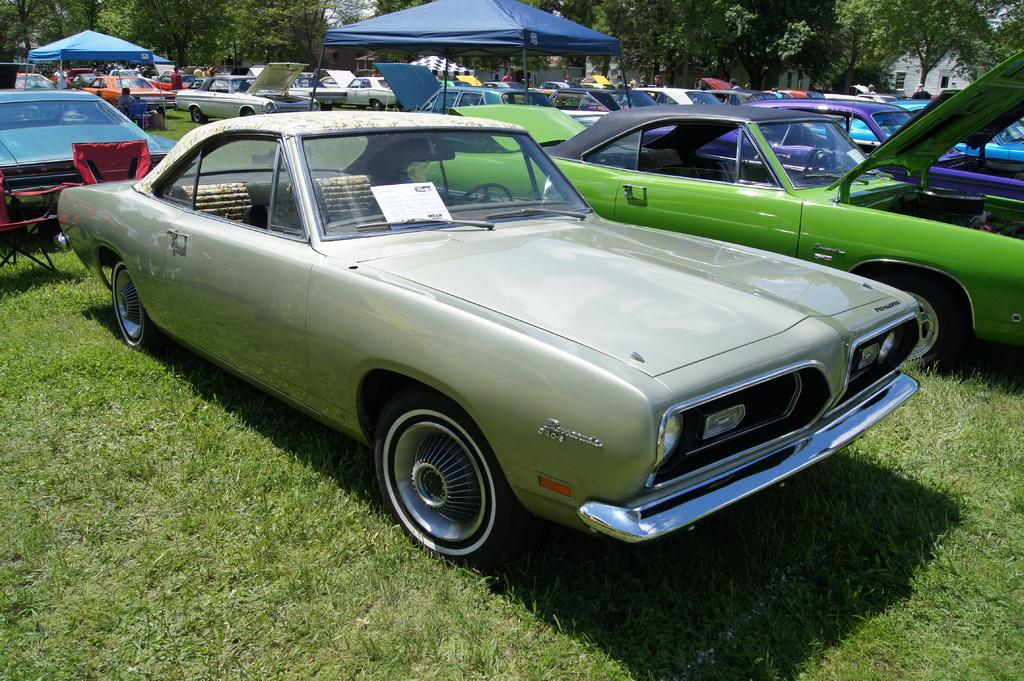What types of vehicles are on the ground in the image? There are motor vehicles on the ground in the image. What type of temporary shelter is visible in the image? There are tents in the image. What type of natural vegetation is present in the image? There are trees in the image. What type of man-made structures are visible in the image? There are buildings in the image. What type of living organisms can be seen in the image? There are persons standing in the image. What type of can is visible in the image? There is no can present in the image. What type of camera is being used to take the image? The image itself does not provide information about the camera used to take it. What level of difficulty is depicted in the image? The image does not depict a level of difficulty; it shows motor vehicles, tents, trees, buildings, and persons standing. 